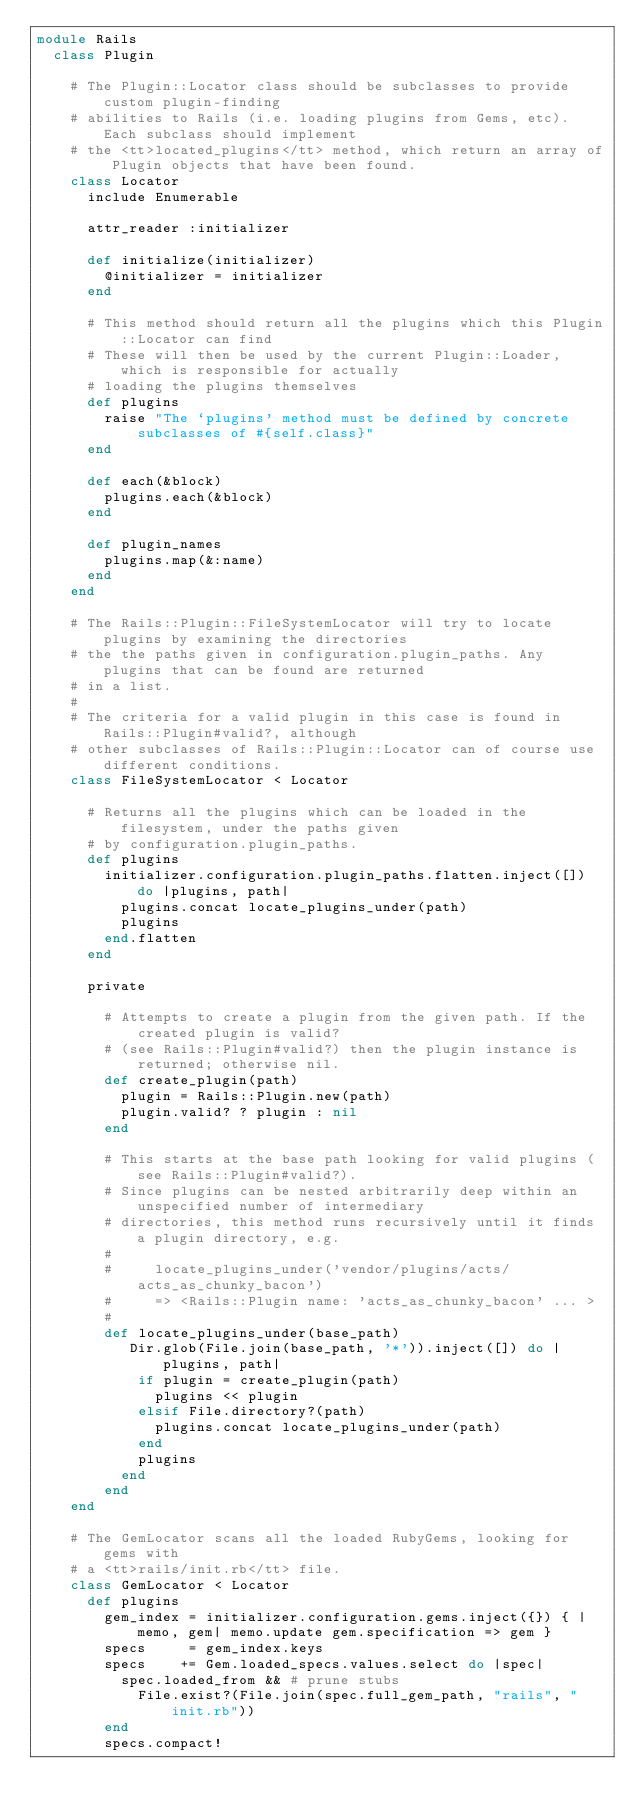Convert code to text. <code><loc_0><loc_0><loc_500><loc_500><_Ruby_>module Rails
  class Plugin
    
    # The Plugin::Locator class should be subclasses to provide custom plugin-finding
    # abilities to Rails (i.e. loading plugins from Gems, etc). Each subclass should implement
    # the <tt>located_plugins</tt> method, which return an array of Plugin objects that have been found.
    class Locator
      include Enumerable
      
      attr_reader :initializer
      
      def initialize(initializer)
        @initializer = initializer
      end
      
      # This method should return all the plugins which this Plugin::Locator can find
      # These will then be used by the current Plugin::Loader, which is responsible for actually
      # loading the plugins themselves
      def plugins
        raise "The `plugins' method must be defined by concrete subclasses of #{self.class}"
      end
      
      def each(&block)
        plugins.each(&block)
      end
      
      def plugin_names
        plugins.map(&:name)
      end
    end
    
    # The Rails::Plugin::FileSystemLocator will try to locate plugins by examining the directories
    # the the paths given in configuration.plugin_paths. Any plugins that can be found are returned
    # in a list. 
    #
    # The criteria for a valid plugin in this case is found in Rails::Plugin#valid?, although
    # other subclasses of Rails::Plugin::Locator can of course use different conditions.
    class FileSystemLocator < Locator
      
      # Returns all the plugins which can be loaded in the filesystem, under the paths given
      # by configuration.plugin_paths.
      def plugins
        initializer.configuration.plugin_paths.flatten.inject([]) do |plugins, path|
          plugins.concat locate_plugins_under(path)
          plugins
        end.flatten
      end
          
      private
      
        # Attempts to create a plugin from the given path. If the created plugin is valid?
        # (see Rails::Plugin#valid?) then the plugin instance is returned; otherwise nil.
        def create_plugin(path)
          plugin = Rails::Plugin.new(path)
          plugin.valid? ? plugin : nil
        end

        # This starts at the base path looking for valid plugins (see Rails::Plugin#valid?).
        # Since plugins can be nested arbitrarily deep within an unspecified number of intermediary 
        # directories, this method runs recursively until it finds a plugin directory, e.g.
        #
        #     locate_plugins_under('vendor/plugins/acts/acts_as_chunky_bacon')
        #     => <Rails::Plugin name: 'acts_as_chunky_bacon' ... >
        #
        def locate_plugins_under(base_path)
           Dir.glob(File.join(base_path, '*')).inject([]) do |plugins, path|
            if plugin = create_plugin(path)
              plugins << plugin
            elsif File.directory?(path)
              plugins.concat locate_plugins_under(path)
            end
            plugins
          end
        end
    end

    # The GemLocator scans all the loaded RubyGems, looking for gems with
    # a <tt>rails/init.rb</tt> file.
    class GemLocator < Locator
      def plugins
        gem_index = initializer.configuration.gems.inject({}) { |memo, gem| memo.update gem.specification => gem }
        specs     = gem_index.keys
        specs    += Gem.loaded_specs.values.select do |spec|
          spec.loaded_from && # prune stubs
            File.exist?(File.join(spec.full_gem_path, "rails", "init.rb"))
        end
        specs.compact!
</code> 